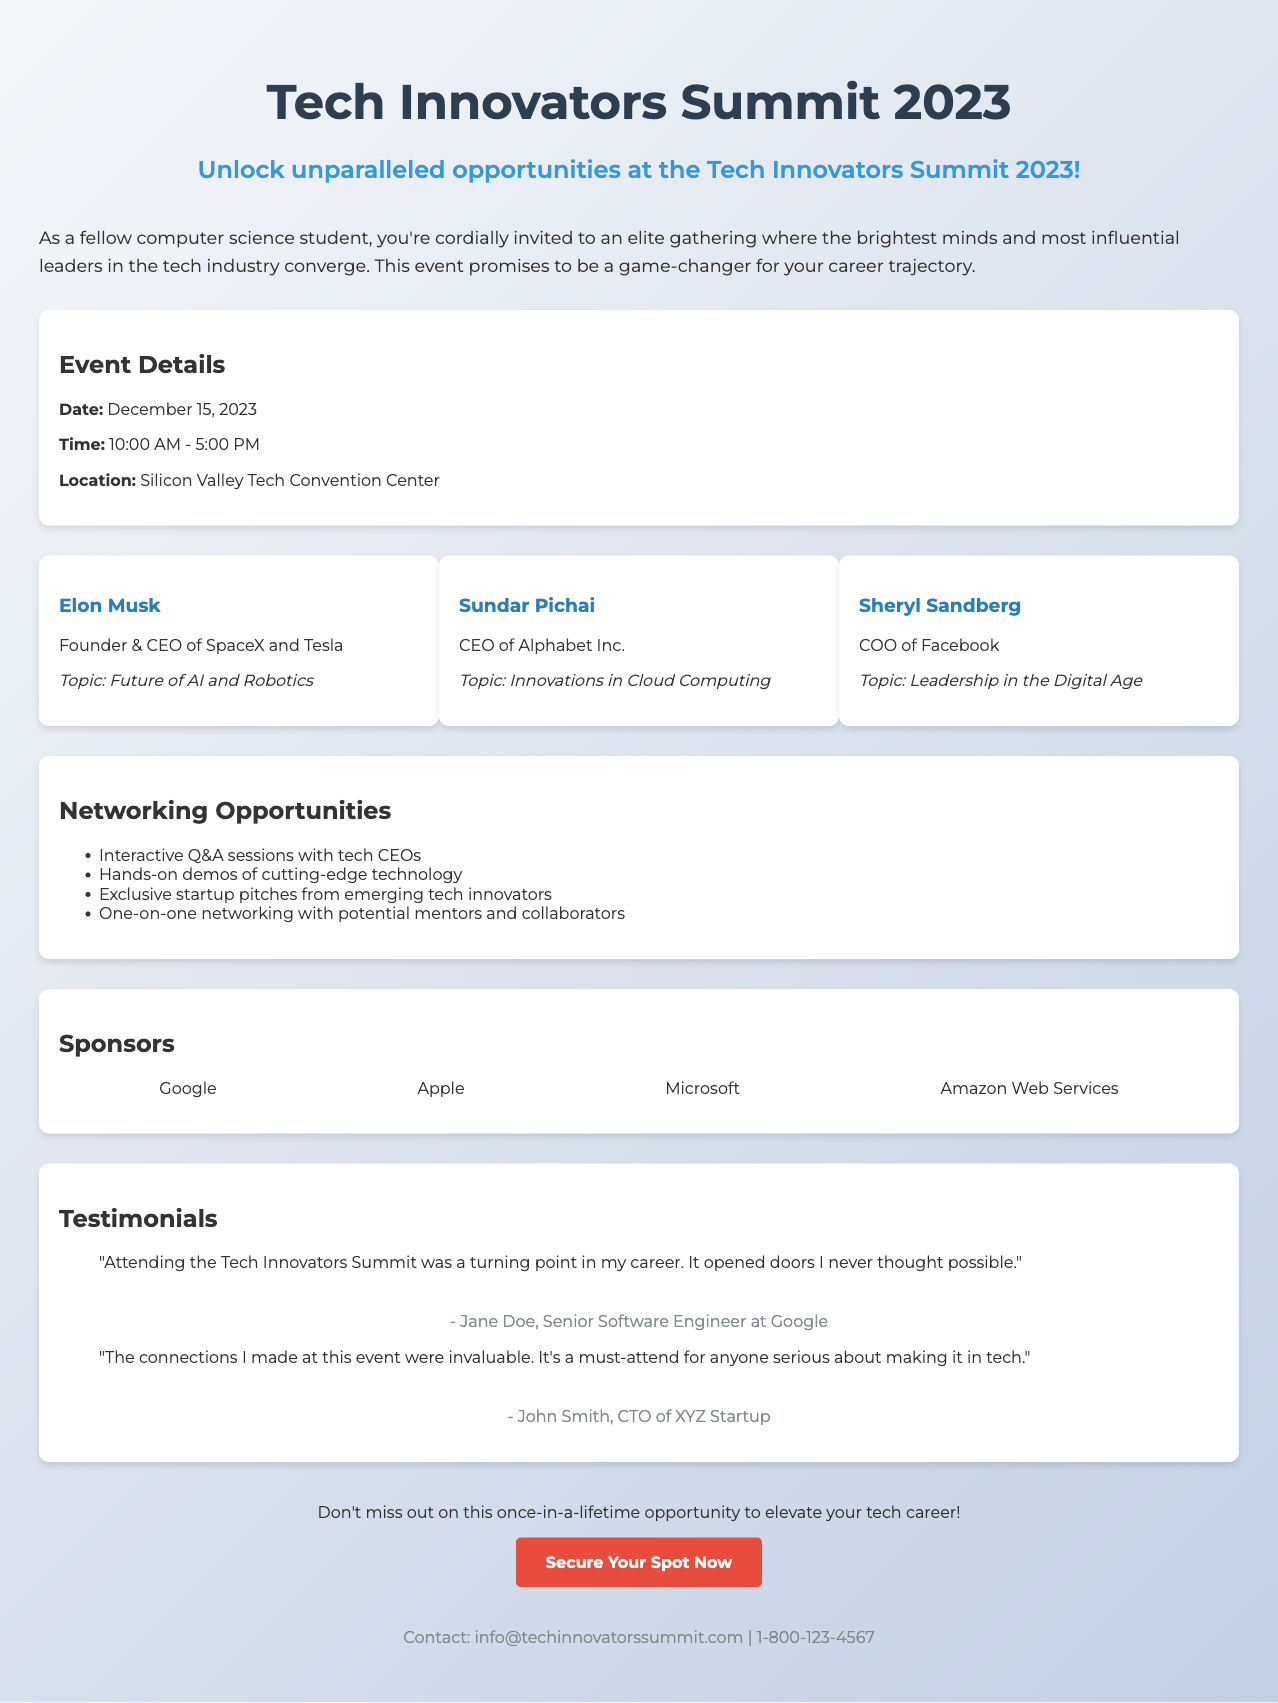What is the date of the event? The document specifies that the event is scheduled for December 15, 2023.
Answer: December 15, 2023 Who is one of the speakers? The document lists several speakers, including Elon Musk, Sundar Pichai, and Sheryl Sandberg.
Answer: Elon Musk What is the location of the event? The document indicates that the event will take place at the Silicon Valley Tech Convention Center.
Answer: Silicon Valley Tech Convention Center What is one of the networking opportunities mentioned? The document lists multiple opportunities, including interactive Q&A sessions with tech CEOs.
Answer: Interactive Q&A sessions Which company is not listed as a sponsor? The document includes sponsors such as Google, Apple, Microsoft, and Amazon Web Services, but not any others.
Answer: None (All listed) What is the time frame of the event? The document states the event runs from 10:00 AM to 5:00 PM.
Answer: 10:00 AM - 5:00 PM What are the testimonials referring to? The testimonials in the document cite the event as a turning point in the careers of attendees and emphasize the value of connections made.
Answer: Turning point in my career Who authored the testimonial from Jane Doe? The document shows that Jane Doe is identified as a Senior Software Engineer at Google.
Answer: Jane Doe What topic will Sheryl Sandberg discuss? The document specifies that Sheryl Sandberg's topic will be "Leadership in the Digital Age."
Answer: Leadership in the Digital Age 